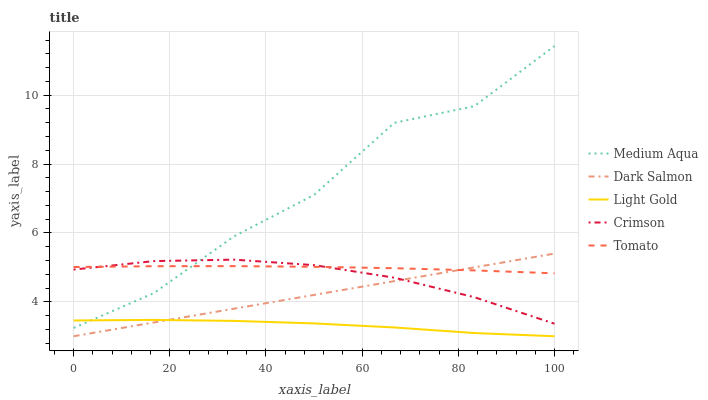Does Light Gold have the minimum area under the curve?
Answer yes or no. Yes. Does Medium Aqua have the maximum area under the curve?
Answer yes or no. Yes. Does Tomato have the minimum area under the curve?
Answer yes or no. No. Does Tomato have the maximum area under the curve?
Answer yes or no. No. Is Dark Salmon the smoothest?
Answer yes or no. Yes. Is Medium Aqua the roughest?
Answer yes or no. Yes. Is Light Gold the smoothest?
Answer yes or no. No. Is Light Gold the roughest?
Answer yes or no. No. Does Light Gold have the lowest value?
Answer yes or no. Yes. Does Tomato have the lowest value?
Answer yes or no. No. Does Medium Aqua have the highest value?
Answer yes or no. Yes. Does Tomato have the highest value?
Answer yes or no. No. Is Dark Salmon less than Medium Aqua?
Answer yes or no. Yes. Is Crimson greater than Light Gold?
Answer yes or no. Yes. Does Medium Aqua intersect Crimson?
Answer yes or no. Yes. Is Medium Aqua less than Crimson?
Answer yes or no. No. Is Medium Aqua greater than Crimson?
Answer yes or no. No. Does Dark Salmon intersect Medium Aqua?
Answer yes or no. No. 